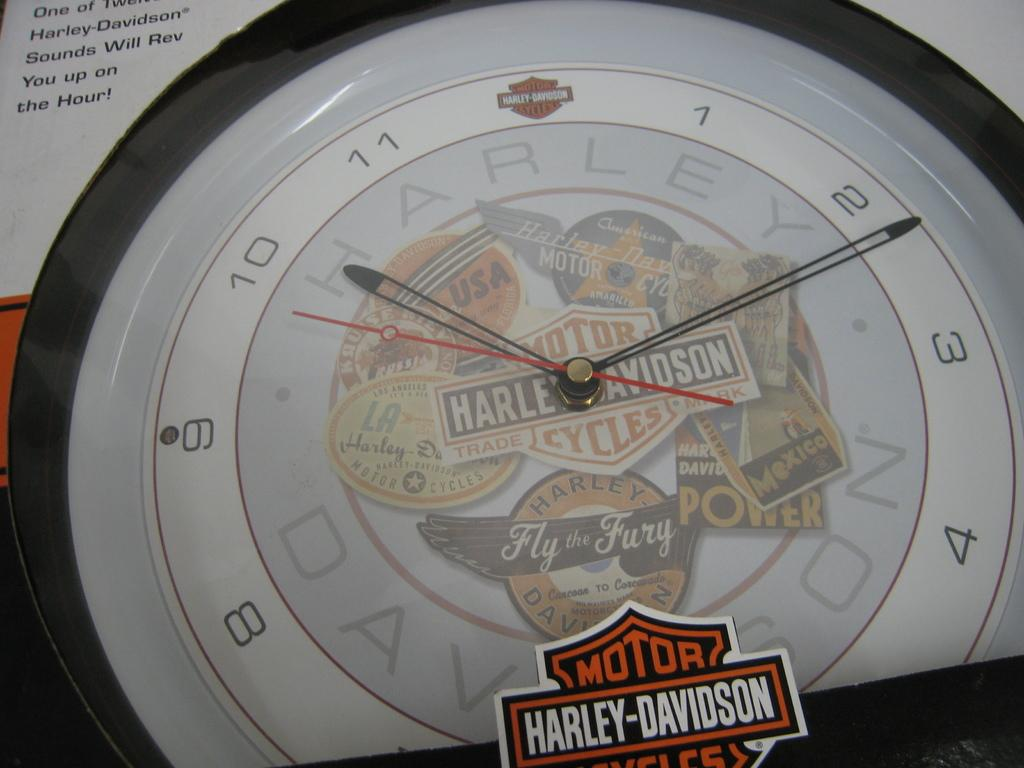<image>
Present a compact description of the photo's key features. A Harley Davidson clock shows the time of 10:12. 